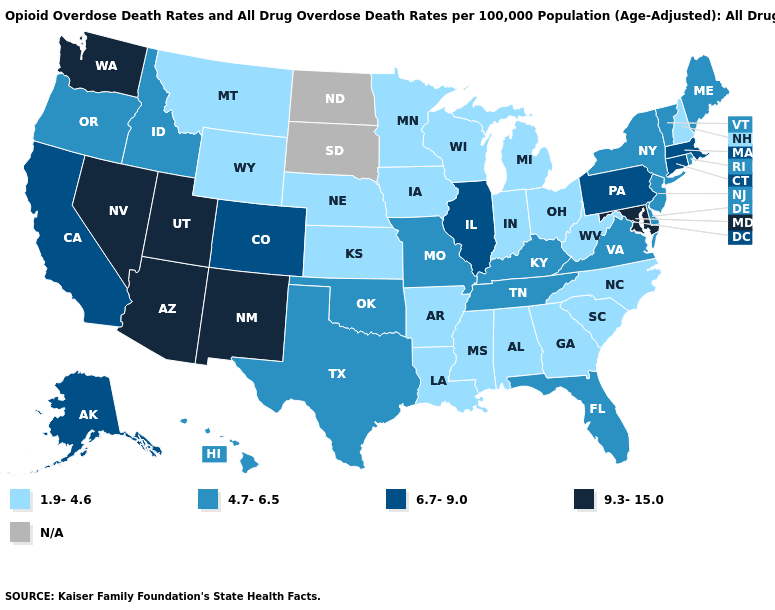Which states have the lowest value in the West?
Quick response, please. Montana, Wyoming. Name the states that have a value in the range 4.7-6.5?
Keep it brief. Delaware, Florida, Hawaii, Idaho, Kentucky, Maine, Missouri, New Jersey, New York, Oklahoma, Oregon, Rhode Island, Tennessee, Texas, Vermont, Virginia. What is the value of Maryland?
Short answer required. 9.3-15.0. Among the states that border New York , which have the lowest value?
Write a very short answer. New Jersey, Vermont. Name the states that have a value in the range 6.7-9.0?
Answer briefly. Alaska, California, Colorado, Connecticut, Illinois, Massachusetts, Pennsylvania. Is the legend a continuous bar?
Be succinct. No. What is the lowest value in states that border Texas?
Keep it brief. 1.9-4.6. Which states have the highest value in the USA?
Keep it brief. Arizona, Maryland, Nevada, New Mexico, Utah, Washington. Name the states that have a value in the range 4.7-6.5?
Answer briefly. Delaware, Florida, Hawaii, Idaho, Kentucky, Maine, Missouri, New Jersey, New York, Oklahoma, Oregon, Rhode Island, Tennessee, Texas, Vermont, Virginia. Name the states that have a value in the range 4.7-6.5?
Be succinct. Delaware, Florida, Hawaii, Idaho, Kentucky, Maine, Missouri, New Jersey, New York, Oklahoma, Oregon, Rhode Island, Tennessee, Texas, Vermont, Virginia. What is the value of South Carolina?
Answer briefly. 1.9-4.6. What is the value of Hawaii?
Keep it brief. 4.7-6.5. Which states have the lowest value in the USA?
Keep it brief. Alabama, Arkansas, Georgia, Indiana, Iowa, Kansas, Louisiana, Michigan, Minnesota, Mississippi, Montana, Nebraska, New Hampshire, North Carolina, Ohio, South Carolina, West Virginia, Wisconsin, Wyoming. 